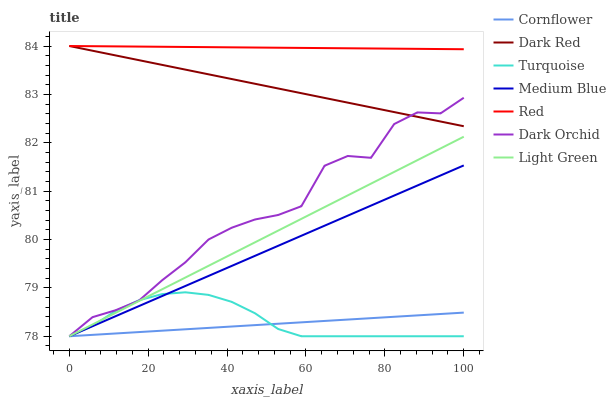Does Turquoise have the minimum area under the curve?
Answer yes or no. No. Does Turquoise have the maximum area under the curve?
Answer yes or no. No. Is Turquoise the smoothest?
Answer yes or no. No. Is Turquoise the roughest?
Answer yes or no. No. Does Dark Red have the lowest value?
Answer yes or no. No. Does Turquoise have the highest value?
Answer yes or no. No. Is Turquoise less than Red?
Answer yes or no. Yes. Is Red greater than Medium Blue?
Answer yes or no. Yes. Does Turquoise intersect Red?
Answer yes or no. No. 